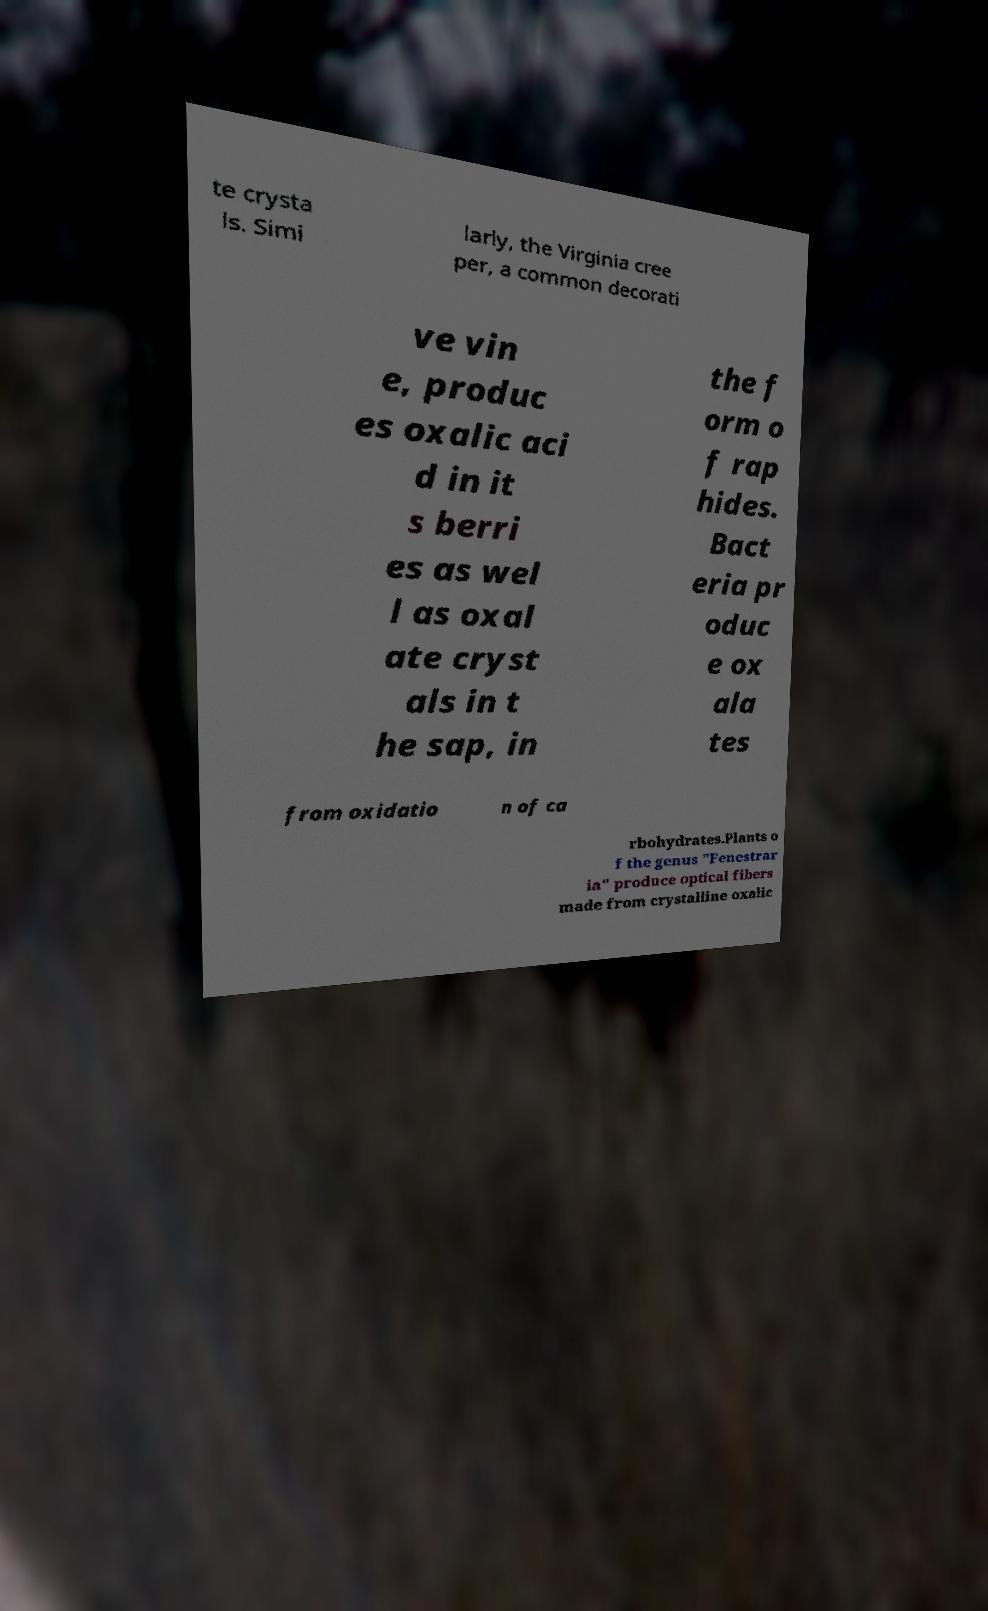Please read and relay the text visible in this image. What does it say? te crysta ls. Simi larly, the Virginia cree per, a common decorati ve vin e, produc es oxalic aci d in it s berri es as wel l as oxal ate cryst als in t he sap, in the f orm o f rap hides. Bact eria pr oduc e ox ala tes from oxidatio n of ca rbohydrates.Plants o f the genus "Fenestrar ia" produce optical fibers made from crystalline oxalic 